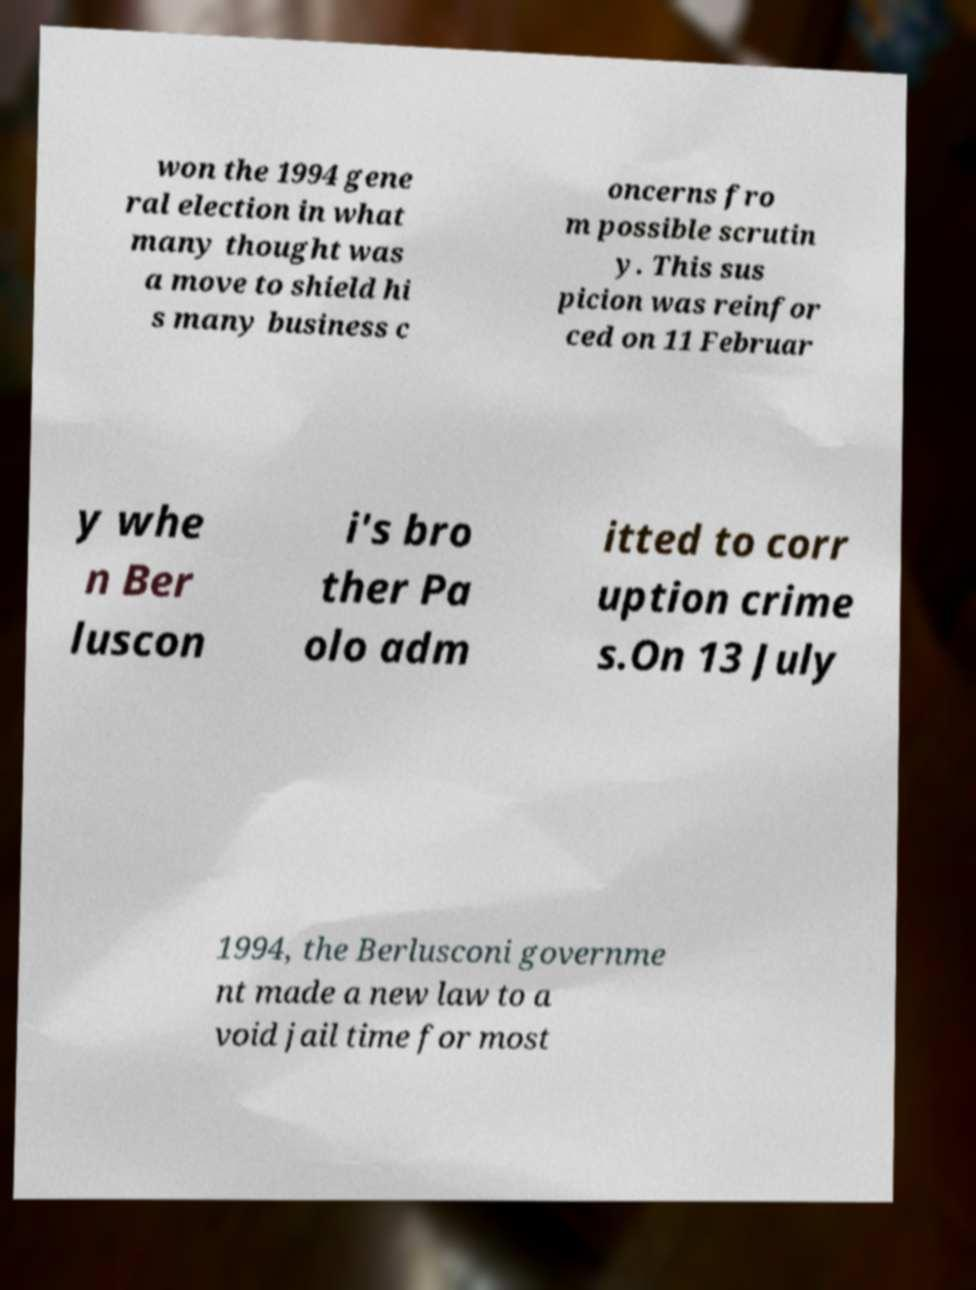Can you accurately transcribe the text from the provided image for me? won the 1994 gene ral election in what many thought was a move to shield hi s many business c oncerns fro m possible scrutin y. This sus picion was reinfor ced on 11 Februar y whe n Ber luscon i's bro ther Pa olo adm itted to corr uption crime s.On 13 July 1994, the Berlusconi governme nt made a new law to a void jail time for most 